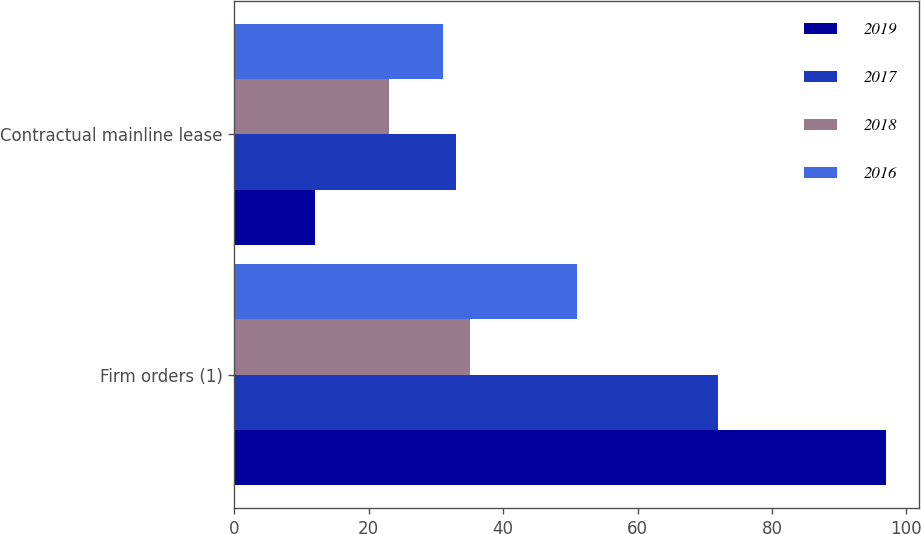Convert chart to OTSL. <chart><loc_0><loc_0><loc_500><loc_500><stacked_bar_chart><ecel><fcel>Firm orders (1)<fcel>Contractual mainline lease<nl><fcel>2019<fcel>97<fcel>12<nl><fcel>2017<fcel>72<fcel>33<nl><fcel>2018<fcel>35<fcel>23<nl><fcel>2016<fcel>51<fcel>31<nl></chart> 